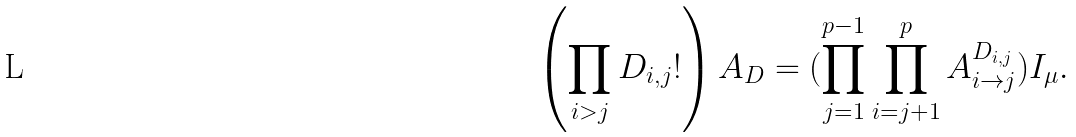<formula> <loc_0><loc_0><loc_500><loc_500>\left ( \prod _ { i > j } D _ { i , j } ! \right ) A _ { D } = ( \prod _ { j = 1 } ^ { p - 1 } \prod _ { i = j + 1 } ^ { p } A _ { i \to j } ^ { D _ { i , j } } ) I _ { \mu } .</formula> 